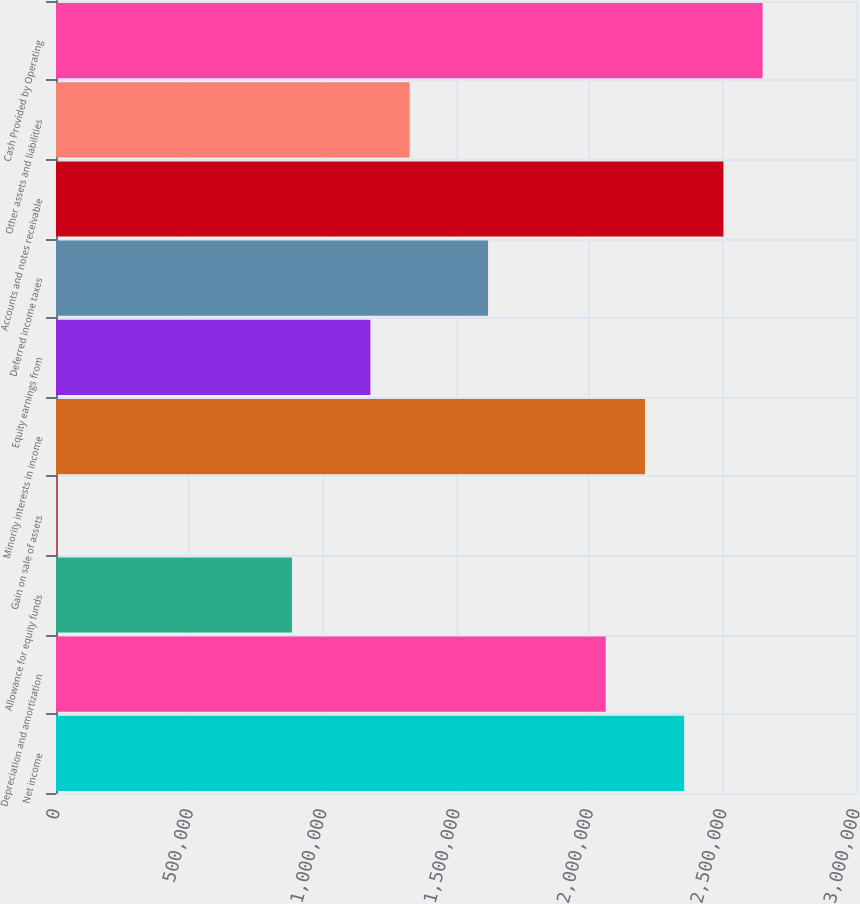Convert chart to OTSL. <chart><loc_0><loc_0><loc_500><loc_500><bar_chart><fcel>Net income<fcel>Depreciation and amortization<fcel>Allowance for equity funds<fcel>Gain on sale of assets<fcel>Minority interests in income<fcel>Equity earnings from<fcel>Deferred income taxes<fcel>Accounts and notes receivable<fcel>Other assets and liabilities<fcel>Cash Provided by Operating<nl><fcel>2.35563e+06<fcel>2.06146e+06<fcel>884808<fcel>2316<fcel>2.20855e+06<fcel>1.17897e+06<fcel>1.62022e+06<fcel>2.50271e+06<fcel>1.32605e+06<fcel>2.64979e+06<nl></chart> 